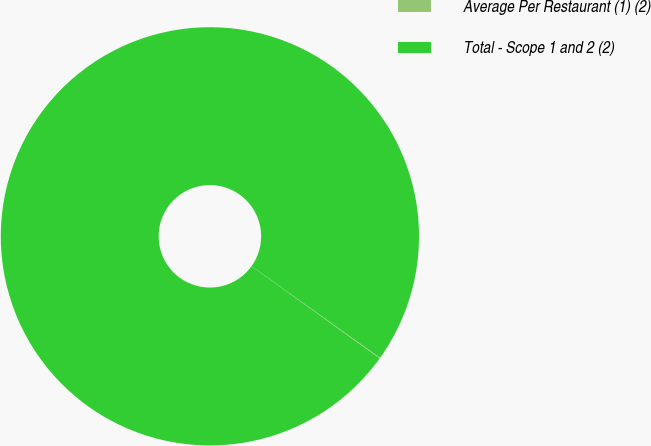<chart> <loc_0><loc_0><loc_500><loc_500><pie_chart><fcel>Average Per Restaurant (1) (2)<fcel>Total - Scope 1 and 2 (2)<nl><fcel>0.06%<fcel>99.94%<nl></chart> 